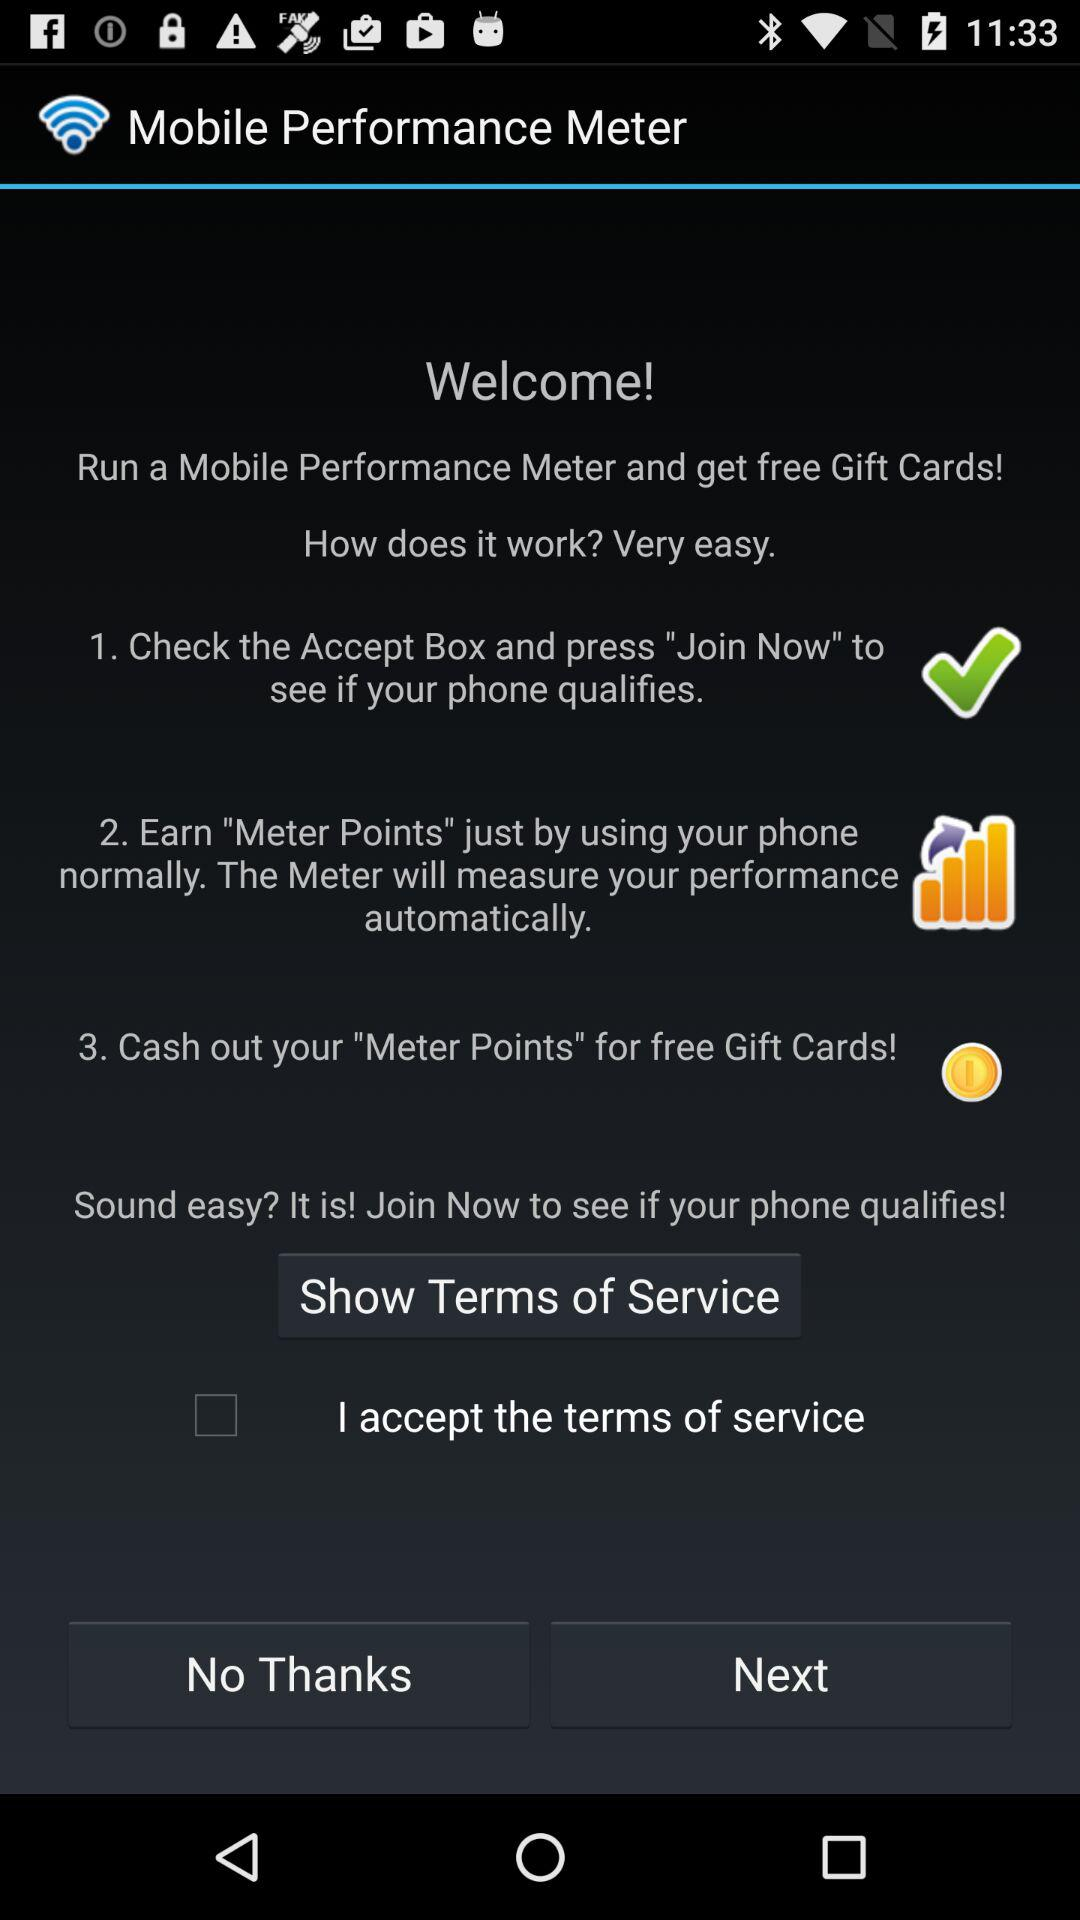When do "Meter Points" expire?
When the provided information is insufficient, respond with <no answer>. <no answer> 